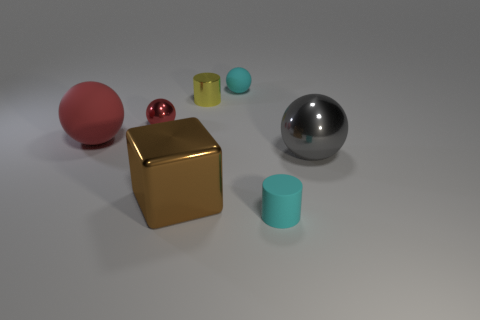Add 2 big brown matte blocks. How many objects exist? 9 Subtract all cubes. How many objects are left? 6 Subtract all yellow objects. Subtract all small yellow metal cylinders. How many objects are left? 5 Add 3 small red things. How many small red things are left? 4 Add 2 cyan cylinders. How many cyan cylinders exist? 3 Subtract 0 brown balls. How many objects are left? 7 